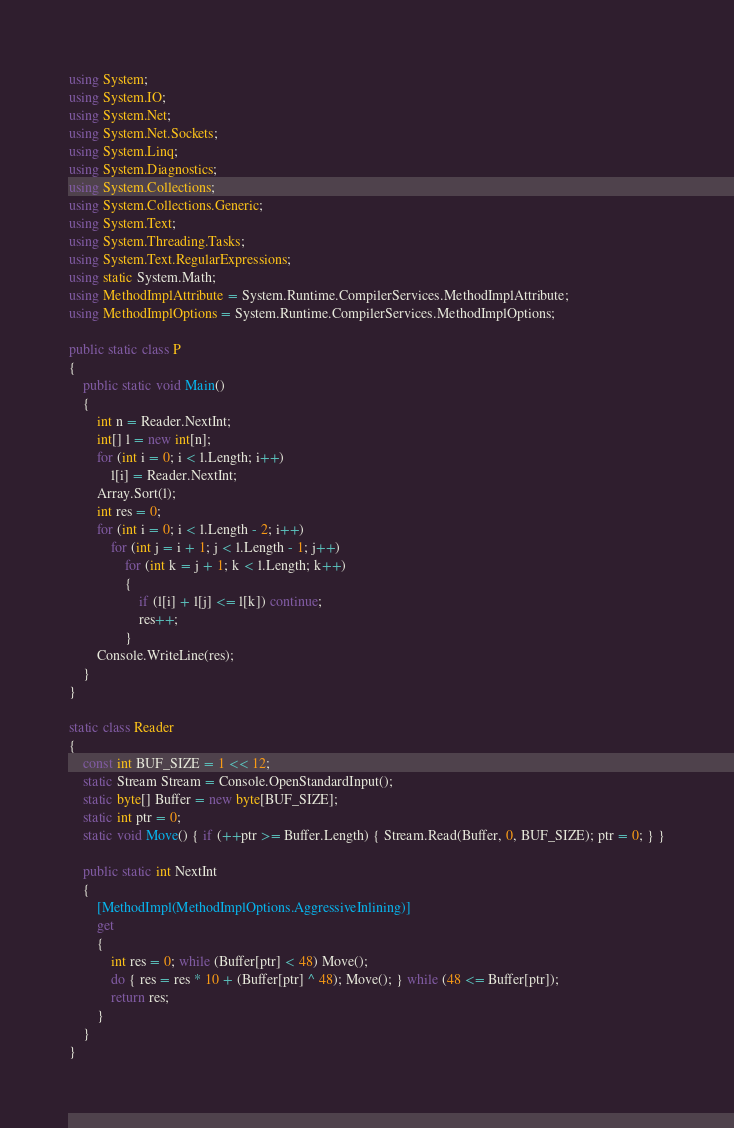<code> <loc_0><loc_0><loc_500><loc_500><_C#_>using System;
using System.IO;
using System.Net;
using System.Net.Sockets;
using System.Linq;
using System.Diagnostics;
using System.Collections;
using System.Collections.Generic;
using System.Text;
using System.Threading.Tasks;
using System.Text.RegularExpressions;
using static System.Math;
using MethodImplAttribute = System.Runtime.CompilerServices.MethodImplAttribute;
using MethodImplOptions = System.Runtime.CompilerServices.MethodImplOptions;

public static class P
{
    public static void Main()
    {
        int n = Reader.NextInt;
        int[] l = new int[n];
        for (int i = 0; i < l.Length; i++)
            l[i] = Reader.NextInt;
        Array.Sort(l);
        int res = 0;
        for (int i = 0; i < l.Length - 2; i++)
            for (int j = i + 1; j < l.Length - 1; j++)
                for (int k = j + 1; k < l.Length; k++)
                {
                    if (l[i] + l[j] <= l[k]) continue;
                    res++;
                }
        Console.WriteLine(res);
    }
}

static class Reader
{
    const int BUF_SIZE = 1 << 12;
    static Stream Stream = Console.OpenStandardInput();
    static byte[] Buffer = new byte[BUF_SIZE];
    static int ptr = 0;
    static void Move() { if (++ptr >= Buffer.Length) { Stream.Read(Buffer, 0, BUF_SIZE); ptr = 0; } }

    public static int NextInt
    {
        [MethodImpl(MethodImplOptions.AggressiveInlining)]
        get
        {
            int res = 0; while (Buffer[ptr] < 48) Move();
            do { res = res * 10 + (Buffer[ptr] ^ 48); Move(); } while (48 <= Buffer[ptr]);
            return res;
        }
    }
}
</code> 